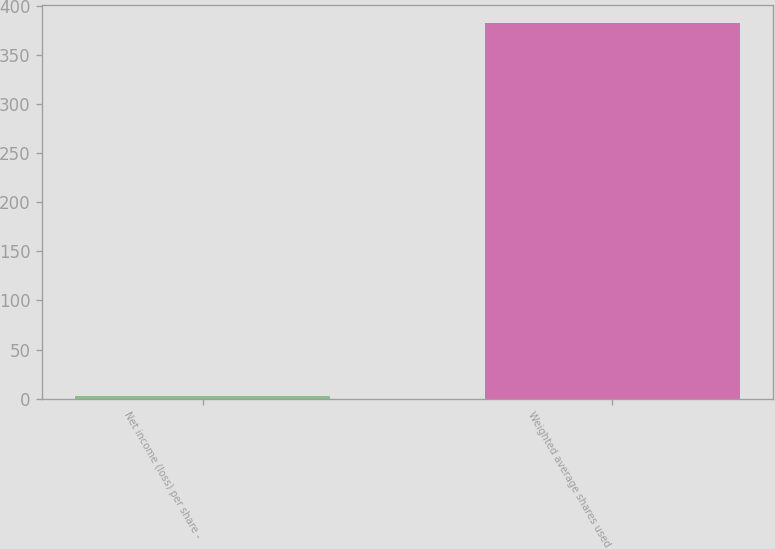<chart> <loc_0><loc_0><loc_500><loc_500><bar_chart><fcel>Net income (loss) per share -<fcel>Weighted average shares used<nl><fcel>2.92<fcel>382.21<nl></chart> 